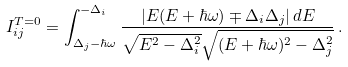<formula> <loc_0><loc_0><loc_500><loc_500>I _ { i j } ^ { T = 0 } = \int _ { \Delta _ { j } - \hbar { \omega } } ^ { - \Delta _ { i } } \frac { | E ( E + \hbar { \omega } ) \mp \Delta _ { i } \Delta _ { j } | \, d E } { \sqrt { E ^ { 2 } - \Delta _ { i } ^ { 2 } } \sqrt { ( E + \hbar { \omega } ) ^ { 2 } - \Delta _ { j } ^ { 2 } } } \, .</formula> 